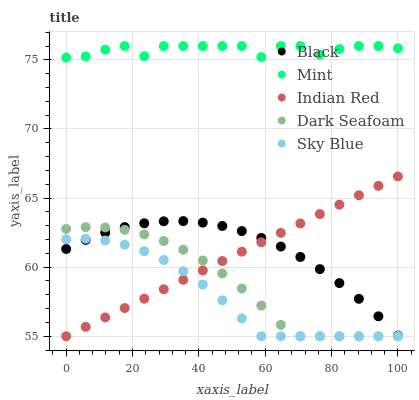Does Sky Blue have the minimum area under the curve?
Answer yes or no. Yes. Does Mint have the maximum area under the curve?
Answer yes or no. Yes. Does Dark Seafoam have the minimum area under the curve?
Answer yes or no. No. Does Dark Seafoam have the maximum area under the curve?
Answer yes or no. No. Is Indian Red the smoothest?
Answer yes or no. Yes. Is Mint the roughest?
Answer yes or no. Yes. Is Dark Seafoam the smoothest?
Answer yes or no. No. Is Dark Seafoam the roughest?
Answer yes or no. No. Does Dark Seafoam have the lowest value?
Answer yes or no. Yes. Does Black have the lowest value?
Answer yes or no. No. Does Mint have the highest value?
Answer yes or no. Yes. Does Dark Seafoam have the highest value?
Answer yes or no. No. Is Black less than Mint?
Answer yes or no. Yes. Is Mint greater than Indian Red?
Answer yes or no. Yes. Does Indian Red intersect Black?
Answer yes or no. Yes. Is Indian Red less than Black?
Answer yes or no. No. Is Indian Red greater than Black?
Answer yes or no. No. Does Black intersect Mint?
Answer yes or no. No. 